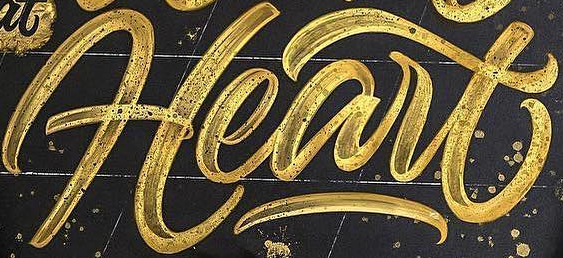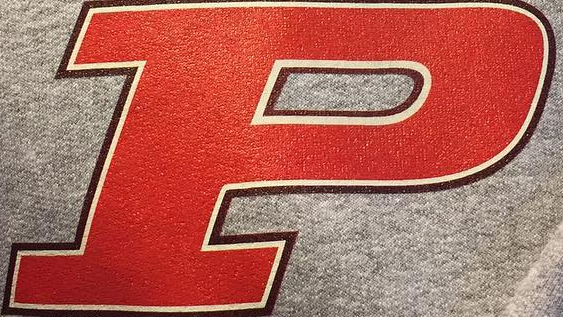What words are shown in these images in order, separated by a semicolon? Heart; P 